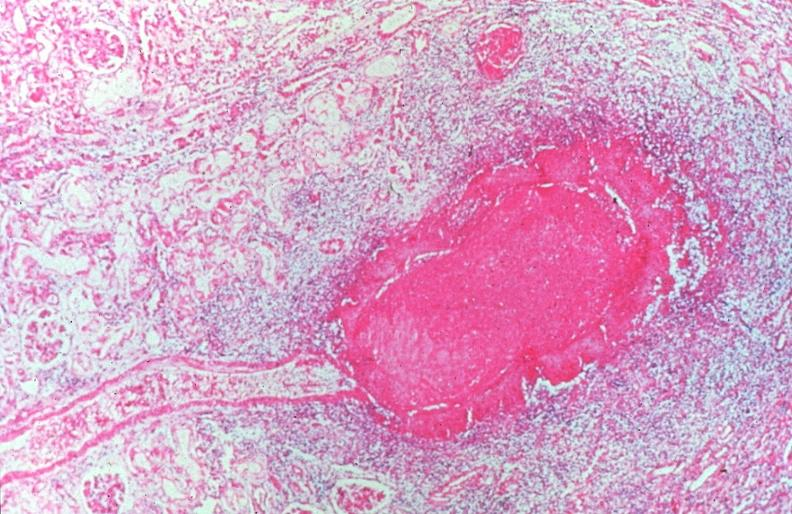s cardiovascular present?
Answer the question using a single word or phrase. Yes 